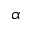<formula> <loc_0><loc_0><loc_500><loc_500>\alpha</formula> 